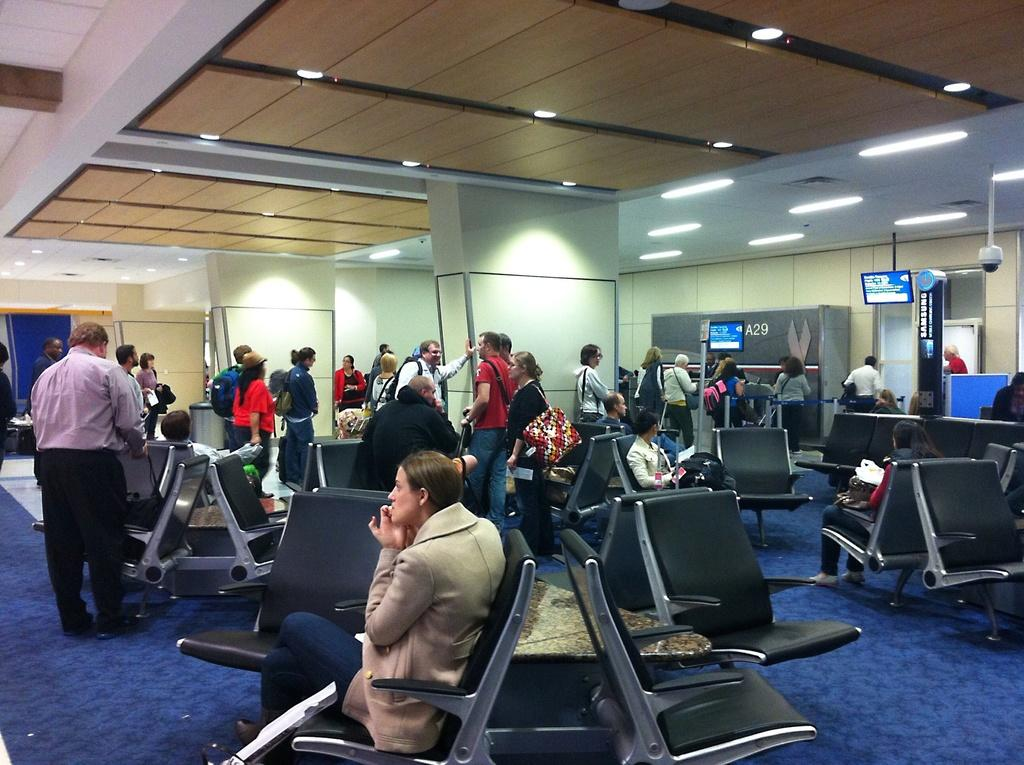What is visible above the people in the image? There is a ceiling visible in the image. What can be seen illuminating the area in the image? There are lights in the image. What type of devices are present in the image? There are screens in the image. What are the people in the image doing? People are standing, walking, and talking to each other in the image. What type of seating is available in the image? There are people sitting on chairs in the image. What is visible below the people in the image? There is a floor visible in the image. What type of dirt can be seen on the yam in the image? There is no dirt or yam present in the image. What type of iron is being used by the people in the image? There is no iron visible in the image; people are standing, walking, and talking to each other. 